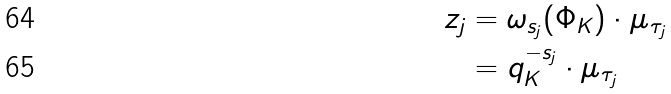Convert formula to latex. <formula><loc_0><loc_0><loc_500><loc_500>z _ { j } & = \omega _ { s _ { j } } ( \Phi _ { K } ) \cdot \mu _ { \tau _ { j } } \\ & = q _ { K } ^ { - s _ { j } } \cdot \mu _ { \tau _ { j } }</formula> 